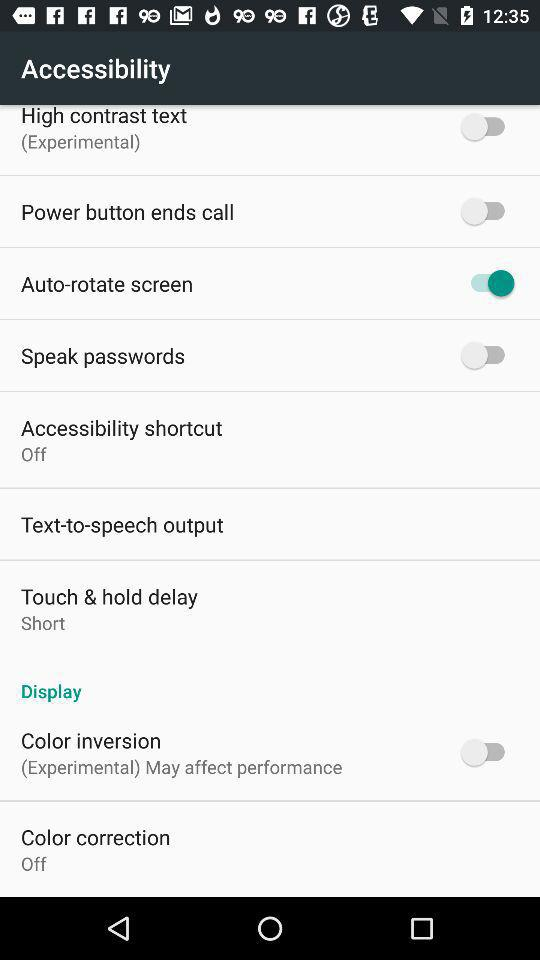What is the status of the "Accessibility shortcut"? The status is "off". 